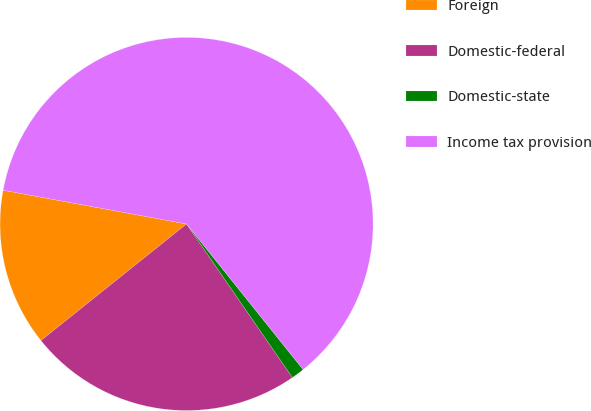<chart> <loc_0><loc_0><loc_500><loc_500><pie_chart><fcel>Foreign<fcel>Domestic-federal<fcel>Domestic-state<fcel>Income tax provision<nl><fcel>13.64%<fcel>23.86%<fcel>1.14%<fcel>61.36%<nl></chart> 